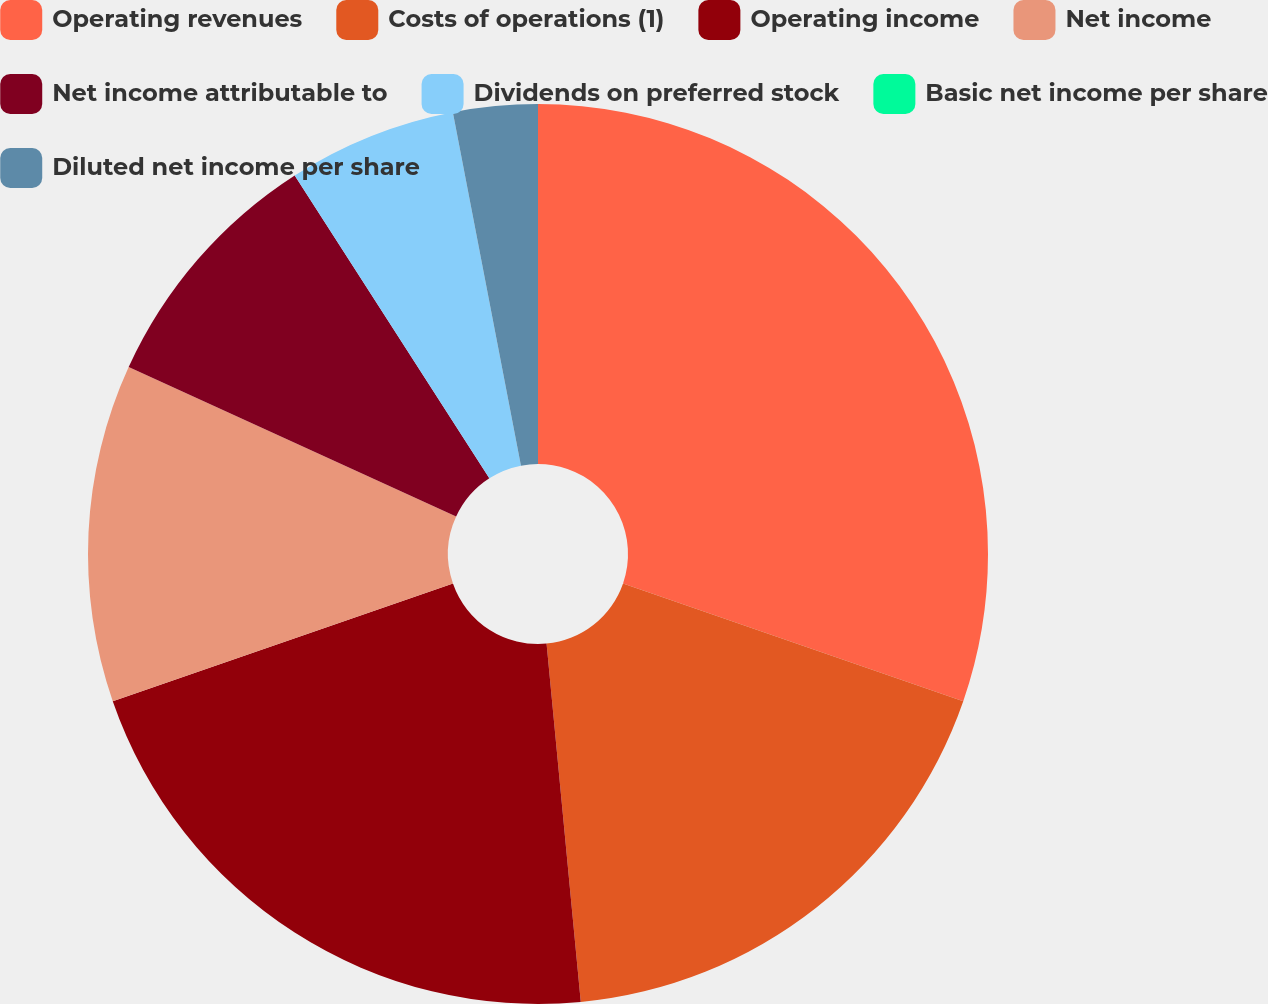<chart> <loc_0><loc_0><loc_500><loc_500><pie_chart><fcel>Operating revenues<fcel>Costs of operations (1)<fcel>Operating income<fcel>Net income<fcel>Net income attributable to<fcel>Dividends on preferred stock<fcel>Basic net income per share<fcel>Diluted net income per share<nl><fcel>30.3%<fcel>18.18%<fcel>21.21%<fcel>12.12%<fcel>9.09%<fcel>6.06%<fcel>0.0%<fcel>3.03%<nl></chart> 